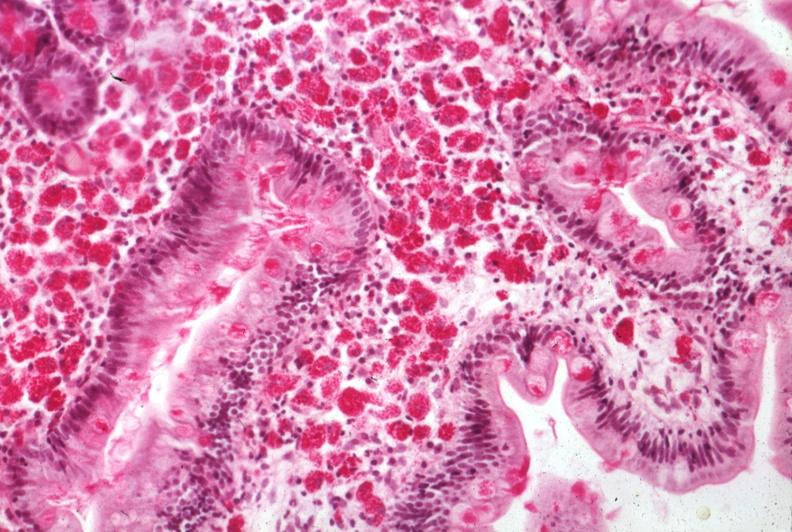s child present?
Answer the question using a single word or phrase. No 